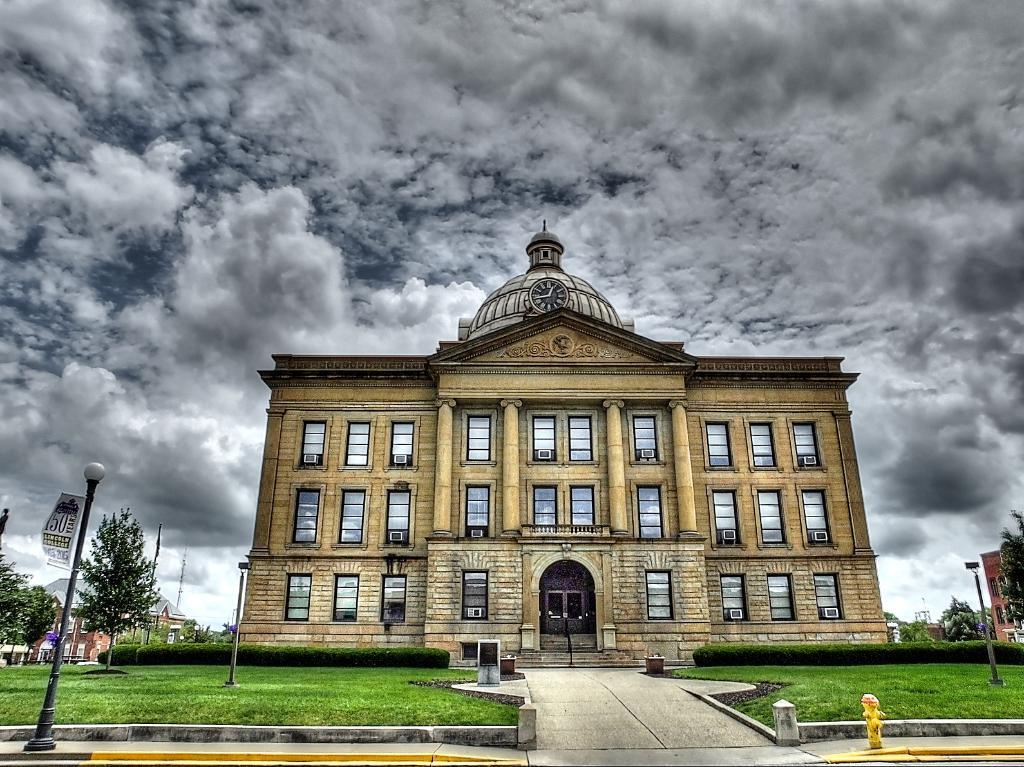What type of building is in the image? There is a palace in the image. What architectural feature can be seen on the palace? The palace has many windows. Is there any time-related object on the palace? Yes, there is a clock on the palace. What can be seen in front of the palace? There is a path with a garden on either side in front of the palace. What is visible in the sky in the image? The sky is visible in the image, and clouds are present. Can you see any ghosts in the image? There are no ghosts present in the image. What year is depicted in the image? The image does not depict a specific year; it is a photograph of a palace, gardens, and sky. 